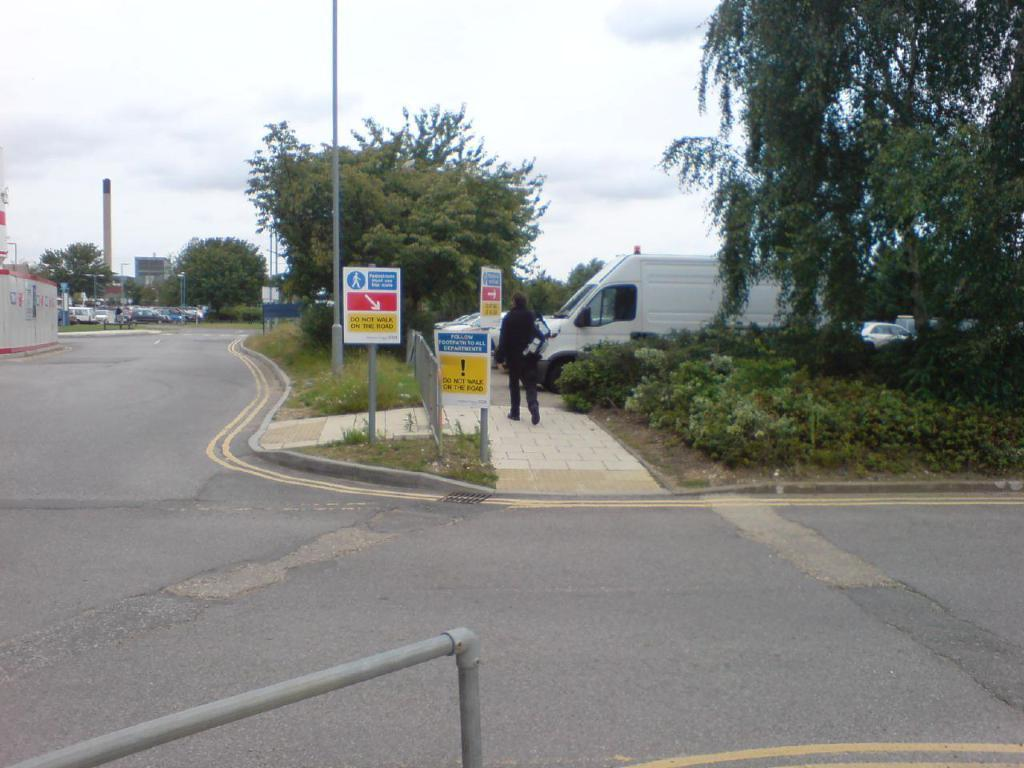Provide a one-sentence caption for the provided image. A number of signs tell people to not walk in the road. 